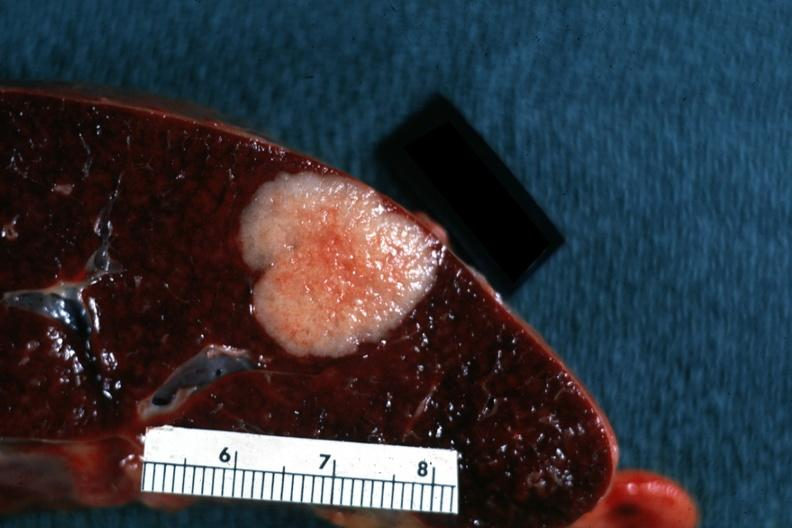s metastatic carcinoma present?
Answer the question using a single word or phrase. Yes 